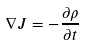Convert formula to latex. <formula><loc_0><loc_0><loc_500><loc_500>\nabla J = - \frac { \partial \rho } { \partial t }</formula> 